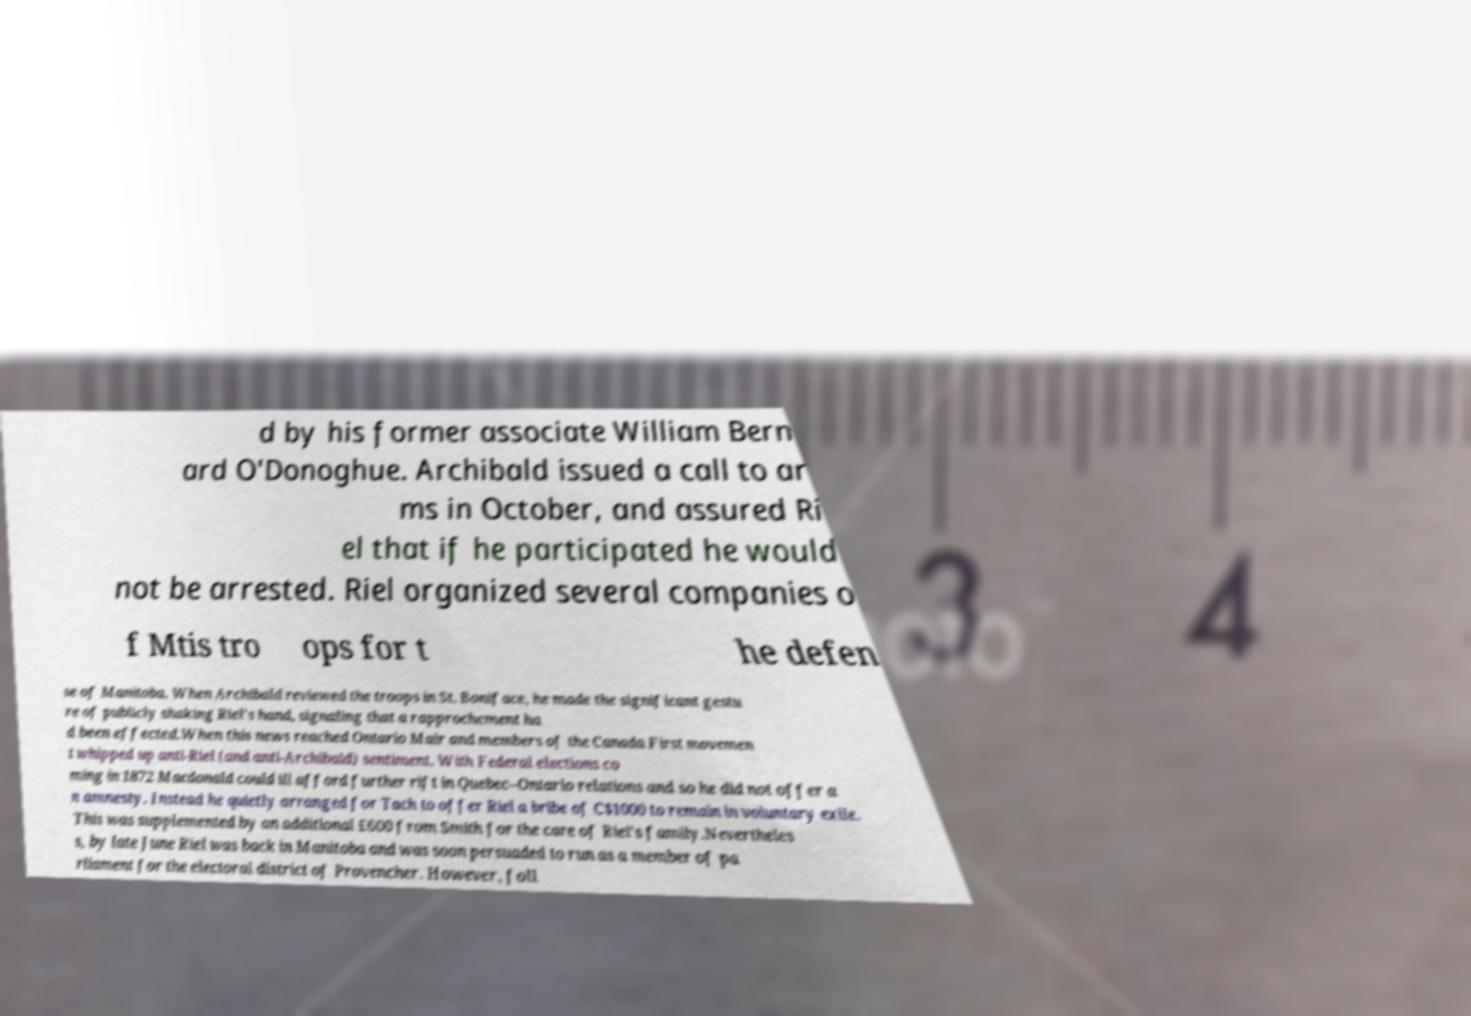Could you extract and type out the text from this image? d by his former associate William Bern ard O'Donoghue. Archibald issued a call to ar ms in October, and assured Ri el that if he participated he would not be arrested. Riel organized several companies o f Mtis tro ops for t he defen se of Manitoba. When Archibald reviewed the troops in St. Boniface, he made the significant gestu re of publicly shaking Riel's hand, signaling that a rapprochement ha d been effected.When this news reached Ontario Mair and members of the Canada First movemen t whipped up anti-Riel (and anti-Archibald) sentiment. With Federal elections co ming in 1872 Macdonald could ill afford further rift in Quebec–Ontario relations and so he did not offer a n amnesty. Instead he quietly arranged for Tach to offer Riel a bribe of C$1000 to remain in voluntary exile. This was supplemented by an additional £600 from Smith for the care of Riel's family.Nevertheles s, by late June Riel was back in Manitoba and was soon persuaded to run as a member of pa rliament for the electoral district of Provencher. However, foll 